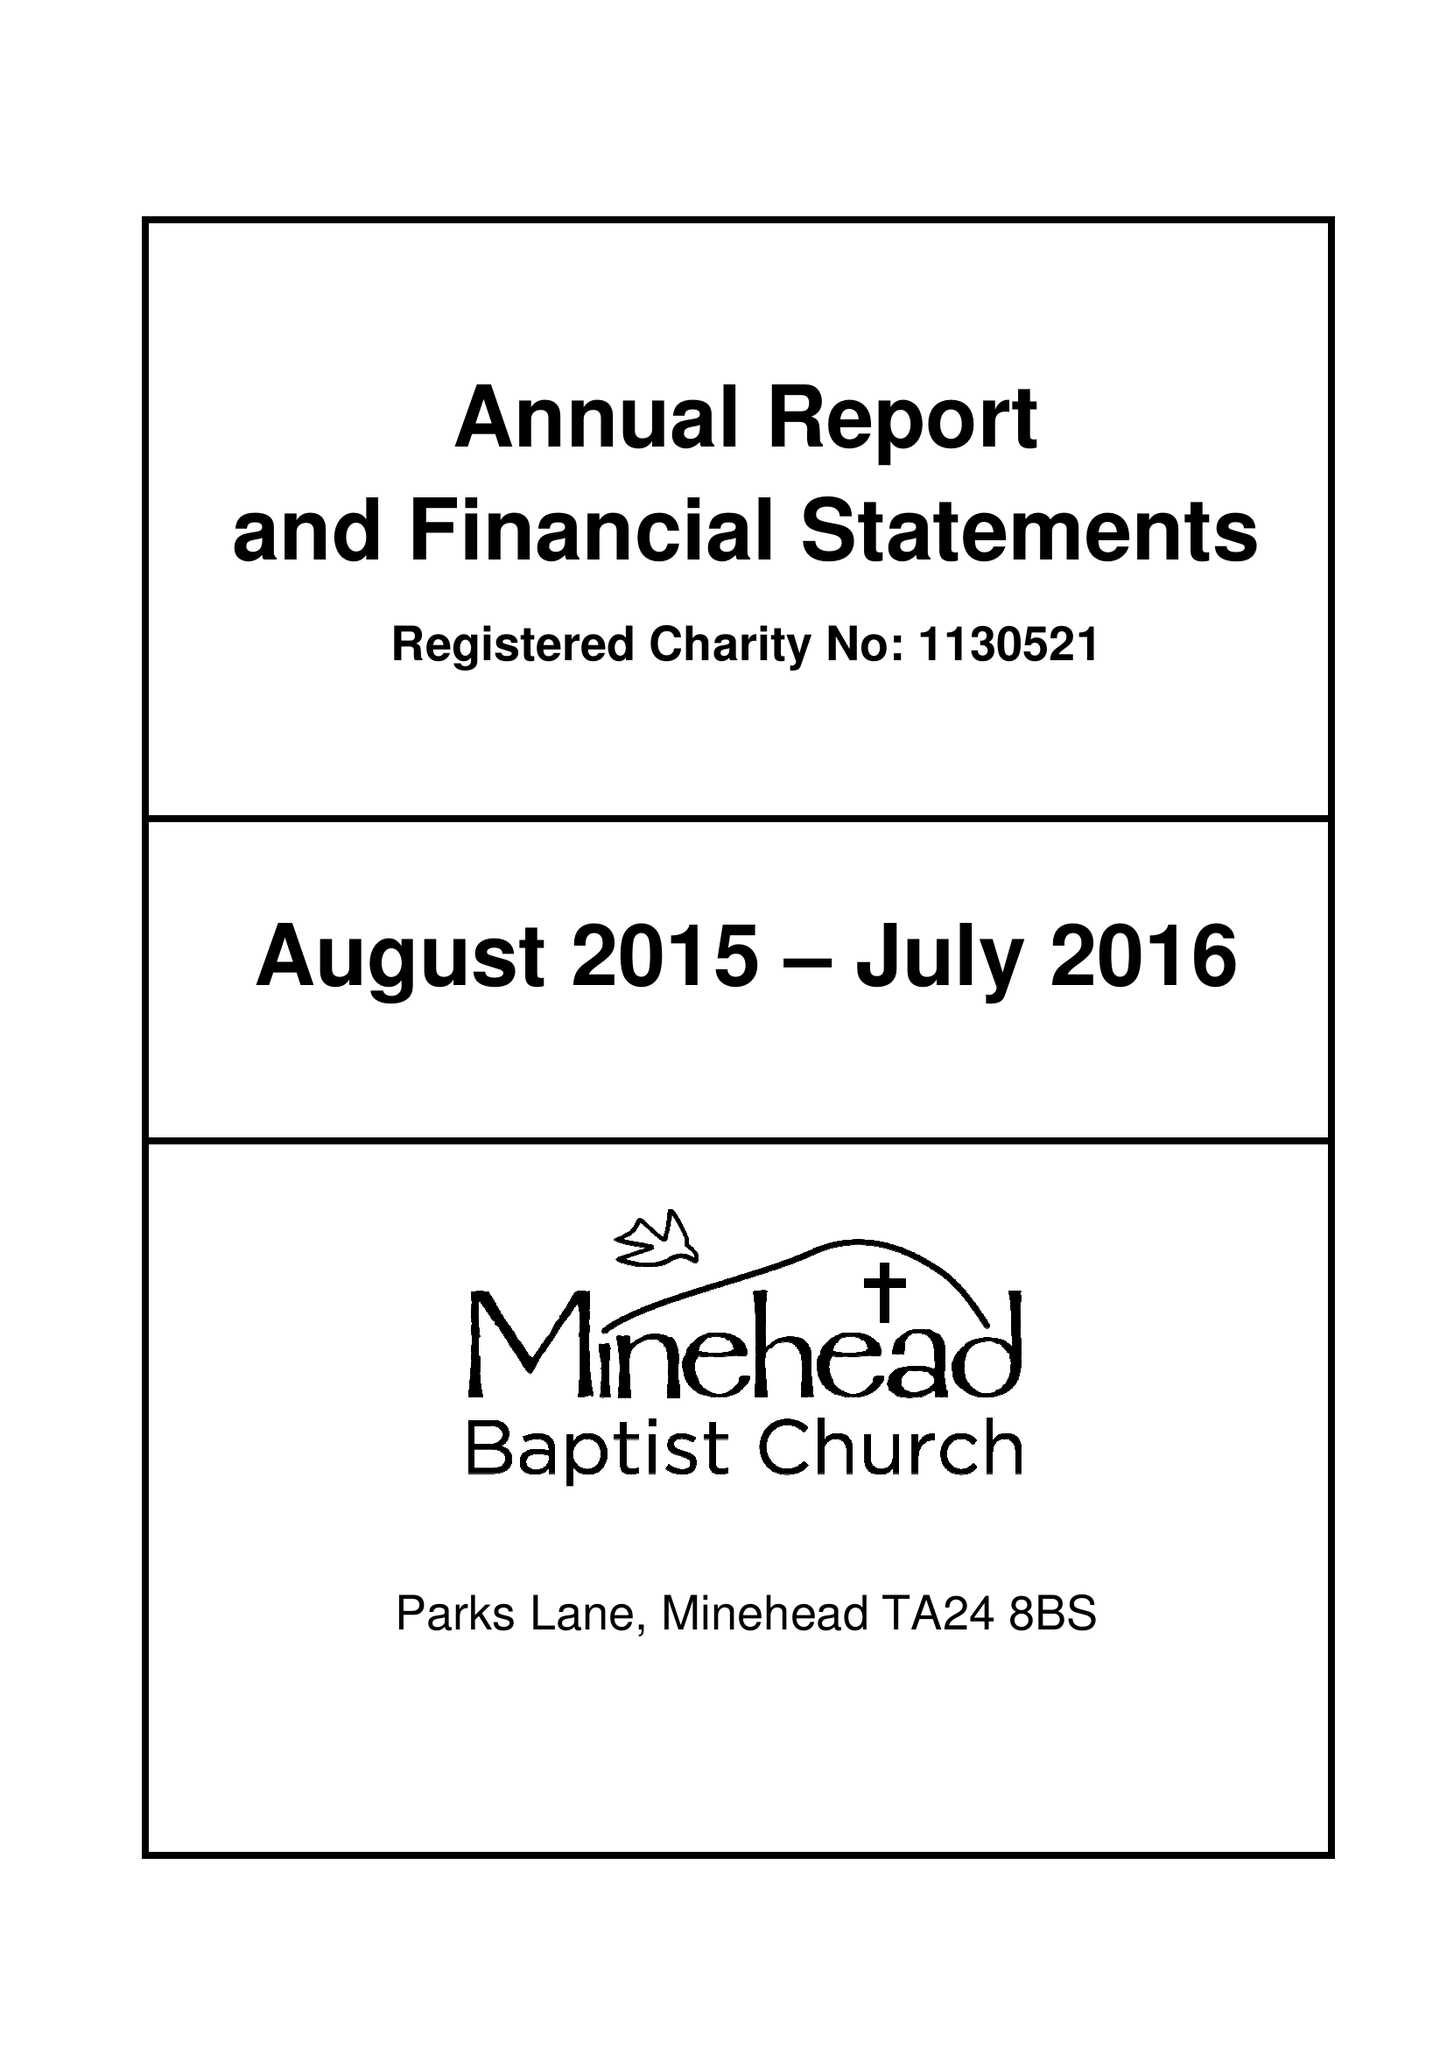What is the value for the charity_number?
Answer the question using a single word or phrase. 1130521 